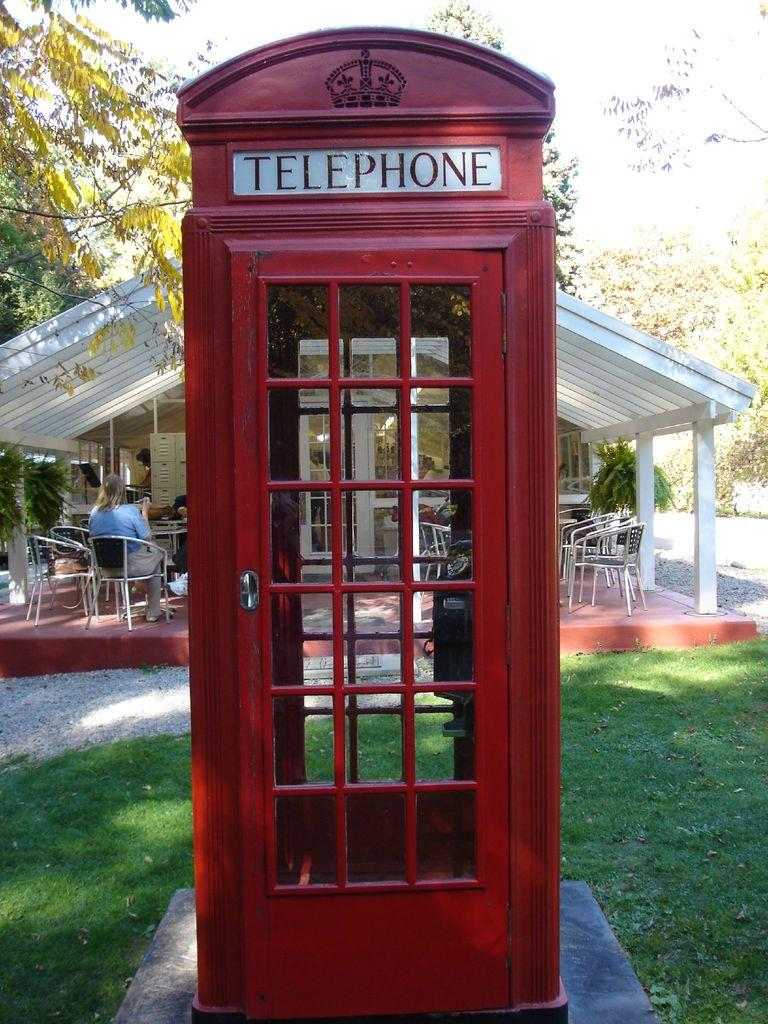What type of structure is in the image? There is a public telephone booth in the image. What can be seen in the background of the image? There are persons sitting on chairs, a shed, trees, the sky, and a plant in the background of the image. What is visible on the ground in the image? The ground is visible in the image. How many quartz rocks can be seen in the image? There are no quartz rocks present in the image. What type of animal is grazing in the background of the image? There are no animals visible in the image, including cows or pigs. 